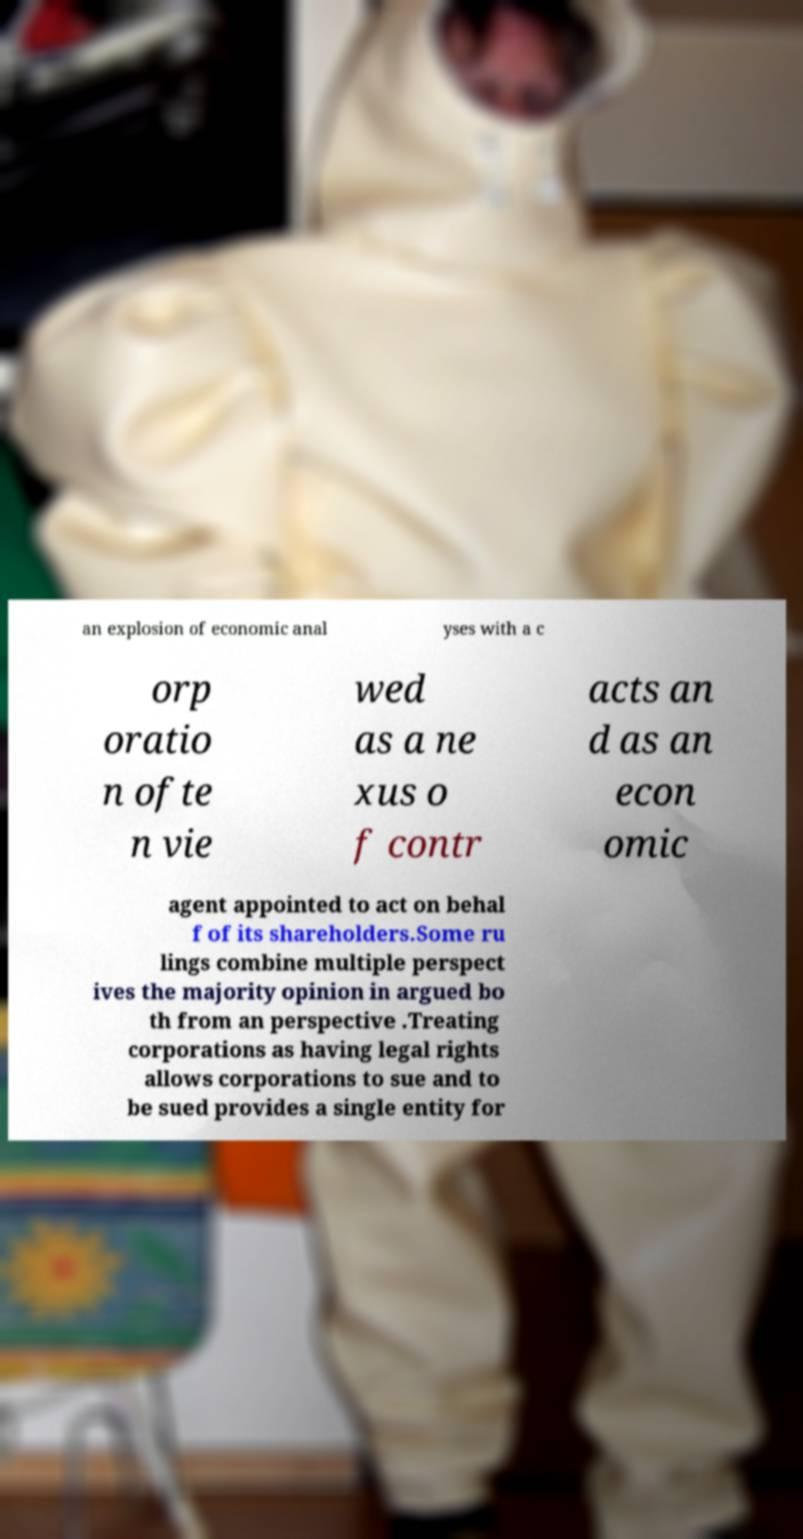Can you accurately transcribe the text from the provided image for me? an explosion of economic anal yses with a c orp oratio n ofte n vie wed as a ne xus o f contr acts an d as an econ omic agent appointed to act on behal f of its shareholders.Some ru lings combine multiple perspect ives the majority opinion in argued bo th from an perspective .Treating corporations as having legal rights allows corporations to sue and to be sued provides a single entity for 